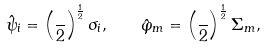<formula> <loc_0><loc_0><loc_500><loc_500>\hat { \psi } _ { i } = \left ( \frac { } { 2 } \right ) ^ { \frac { 1 } { 2 } } \sigma _ { i } , \quad \hat { \varphi } _ { m } = \left ( \frac { } { 2 } \right ) ^ { \frac { 1 } { 2 } } \Sigma _ { m } ,</formula> 